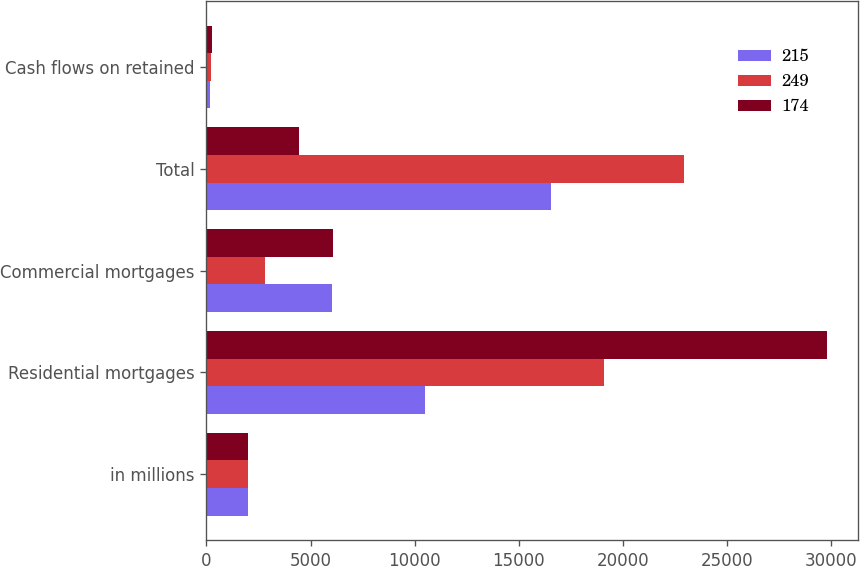Convert chart. <chart><loc_0><loc_0><loc_500><loc_500><stacked_bar_chart><ecel><fcel>in millions<fcel>Residential mortgages<fcel>Commercial mortgages<fcel>Total<fcel>Cash flows on retained<nl><fcel>215<fcel>2015<fcel>10479<fcel>6043<fcel>16522<fcel>174<nl><fcel>249<fcel>2014<fcel>19099<fcel>2810<fcel>22918<fcel>215<nl><fcel>174<fcel>2013<fcel>29772<fcel>6086<fcel>4426.5<fcel>249<nl></chart> 